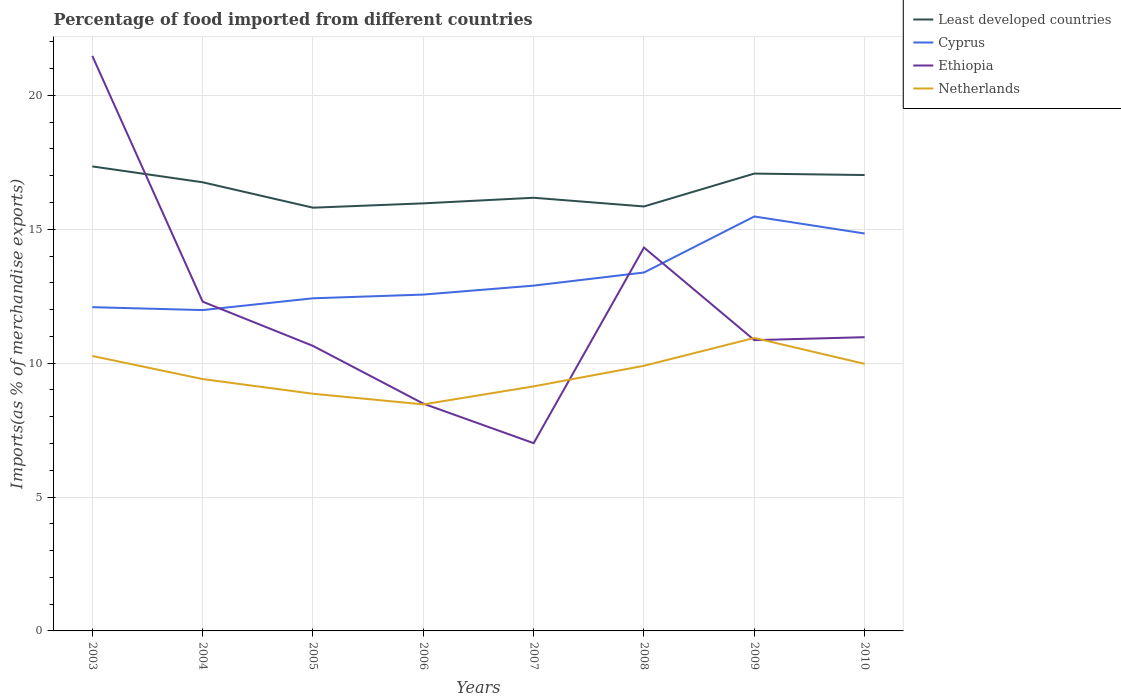How many different coloured lines are there?
Your answer should be compact. 4. Does the line corresponding to Least developed countries intersect with the line corresponding to Cyprus?
Offer a very short reply. No. Is the number of lines equal to the number of legend labels?
Your response must be concise. Yes. Across all years, what is the maximum percentage of imports to different countries in Netherlands?
Keep it short and to the point. 8.46. In which year was the percentage of imports to different countries in Ethiopia maximum?
Your answer should be compact. 2007. What is the total percentage of imports to different countries in Netherlands in the graph?
Ensure brevity in your answer.  0.4. What is the difference between the highest and the second highest percentage of imports to different countries in Ethiopia?
Provide a succinct answer. 14.46. What is the difference between the highest and the lowest percentage of imports to different countries in Least developed countries?
Provide a succinct answer. 4. How many years are there in the graph?
Offer a very short reply. 8. What is the difference between two consecutive major ticks on the Y-axis?
Ensure brevity in your answer.  5. Does the graph contain any zero values?
Make the answer very short. No. Does the graph contain grids?
Keep it short and to the point. Yes. Where does the legend appear in the graph?
Your response must be concise. Top right. What is the title of the graph?
Your response must be concise. Percentage of food imported from different countries. Does "East Asia (developing only)" appear as one of the legend labels in the graph?
Offer a very short reply. No. What is the label or title of the Y-axis?
Provide a succinct answer. Imports(as % of merchandise exports). What is the Imports(as % of merchandise exports) of Least developed countries in 2003?
Make the answer very short. 17.35. What is the Imports(as % of merchandise exports) of Cyprus in 2003?
Provide a short and direct response. 12.09. What is the Imports(as % of merchandise exports) of Ethiopia in 2003?
Offer a terse response. 21.47. What is the Imports(as % of merchandise exports) in Netherlands in 2003?
Provide a short and direct response. 10.27. What is the Imports(as % of merchandise exports) of Least developed countries in 2004?
Keep it short and to the point. 16.76. What is the Imports(as % of merchandise exports) in Cyprus in 2004?
Make the answer very short. 11.98. What is the Imports(as % of merchandise exports) in Ethiopia in 2004?
Provide a succinct answer. 12.3. What is the Imports(as % of merchandise exports) of Netherlands in 2004?
Give a very brief answer. 9.41. What is the Imports(as % of merchandise exports) of Least developed countries in 2005?
Offer a very short reply. 15.81. What is the Imports(as % of merchandise exports) in Cyprus in 2005?
Offer a very short reply. 12.42. What is the Imports(as % of merchandise exports) of Ethiopia in 2005?
Provide a succinct answer. 10.64. What is the Imports(as % of merchandise exports) in Netherlands in 2005?
Your answer should be very brief. 8.86. What is the Imports(as % of merchandise exports) in Least developed countries in 2006?
Your response must be concise. 15.97. What is the Imports(as % of merchandise exports) of Cyprus in 2006?
Provide a succinct answer. 12.56. What is the Imports(as % of merchandise exports) of Ethiopia in 2006?
Keep it short and to the point. 8.49. What is the Imports(as % of merchandise exports) of Netherlands in 2006?
Provide a short and direct response. 8.46. What is the Imports(as % of merchandise exports) in Least developed countries in 2007?
Your answer should be very brief. 16.18. What is the Imports(as % of merchandise exports) in Cyprus in 2007?
Provide a short and direct response. 12.9. What is the Imports(as % of merchandise exports) of Ethiopia in 2007?
Your response must be concise. 7.01. What is the Imports(as % of merchandise exports) in Netherlands in 2007?
Ensure brevity in your answer.  9.13. What is the Imports(as % of merchandise exports) in Least developed countries in 2008?
Offer a terse response. 15.85. What is the Imports(as % of merchandise exports) of Cyprus in 2008?
Your response must be concise. 13.39. What is the Imports(as % of merchandise exports) in Ethiopia in 2008?
Provide a succinct answer. 14.32. What is the Imports(as % of merchandise exports) in Netherlands in 2008?
Your answer should be compact. 9.9. What is the Imports(as % of merchandise exports) in Least developed countries in 2009?
Provide a short and direct response. 17.08. What is the Imports(as % of merchandise exports) of Cyprus in 2009?
Provide a succinct answer. 15.48. What is the Imports(as % of merchandise exports) in Ethiopia in 2009?
Your response must be concise. 10.86. What is the Imports(as % of merchandise exports) of Netherlands in 2009?
Ensure brevity in your answer.  10.94. What is the Imports(as % of merchandise exports) in Least developed countries in 2010?
Keep it short and to the point. 17.03. What is the Imports(as % of merchandise exports) in Cyprus in 2010?
Your answer should be very brief. 14.84. What is the Imports(as % of merchandise exports) of Ethiopia in 2010?
Provide a short and direct response. 10.97. What is the Imports(as % of merchandise exports) in Netherlands in 2010?
Your response must be concise. 9.97. Across all years, what is the maximum Imports(as % of merchandise exports) of Least developed countries?
Keep it short and to the point. 17.35. Across all years, what is the maximum Imports(as % of merchandise exports) in Cyprus?
Your answer should be very brief. 15.48. Across all years, what is the maximum Imports(as % of merchandise exports) of Ethiopia?
Your response must be concise. 21.47. Across all years, what is the maximum Imports(as % of merchandise exports) of Netherlands?
Ensure brevity in your answer.  10.94. Across all years, what is the minimum Imports(as % of merchandise exports) of Least developed countries?
Your answer should be very brief. 15.81. Across all years, what is the minimum Imports(as % of merchandise exports) in Cyprus?
Ensure brevity in your answer.  11.98. Across all years, what is the minimum Imports(as % of merchandise exports) of Ethiopia?
Your answer should be compact. 7.01. Across all years, what is the minimum Imports(as % of merchandise exports) of Netherlands?
Ensure brevity in your answer.  8.46. What is the total Imports(as % of merchandise exports) of Least developed countries in the graph?
Your answer should be compact. 132.02. What is the total Imports(as % of merchandise exports) in Cyprus in the graph?
Your response must be concise. 105.66. What is the total Imports(as % of merchandise exports) of Ethiopia in the graph?
Provide a short and direct response. 96.07. What is the total Imports(as % of merchandise exports) of Netherlands in the graph?
Make the answer very short. 76.95. What is the difference between the Imports(as % of merchandise exports) of Least developed countries in 2003 and that in 2004?
Your answer should be very brief. 0.59. What is the difference between the Imports(as % of merchandise exports) in Cyprus in 2003 and that in 2004?
Your answer should be compact. 0.11. What is the difference between the Imports(as % of merchandise exports) of Ethiopia in 2003 and that in 2004?
Offer a very short reply. 9.18. What is the difference between the Imports(as % of merchandise exports) in Netherlands in 2003 and that in 2004?
Make the answer very short. 0.86. What is the difference between the Imports(as % of merchandise exports) in Least developed countries in 2003 and that in 2005?
Your answer should be compact. 1.54. What is the difference between the Imports(as % of merchandise exports) of Cyprus in 2003 and that in 2005?
Keep it short and to the point. -0.33. What is the difference between the Imports(as % of merchandise exports) in Ethiopia in 2003 and that in 2005?
Ensure brevity in your answer.  10.83. What is the difference between the Imports(as % of merchandise exports) in Netherlands in 2003 and that in 2005?
Make the answer very short. 1.41. What is the difference between the Imports(as % of merchandise exports) in Least developed countries in 2003 and that in 2006?
Your answer should be compact. 1.38. What is the difference between the Imports(as % of merchandise exports) in Cyprus in 2003 and that in 2006?
Keep it short and to the point. -0.47. What is the difference between the Imports(as % of merchandise exports) of Ethiopia in 2003 and that in 2006?
Make the answer very short. 12.99. What is the difference between the Imports(as % of merchandise exports) in Netherlands in 2003 and that in 2006?
Keep it short and to the point. 1.81. What is the difference between the Imports(as % of merchandise exports) in Least developed countries in 2003 and that in 2007?
Offer a very short reply. 1.17. What is the difference between the Imports(as % of merchandise exports) in Cyprus in 2003 and that in 2007?
Make the answer very short. -0.81. What is the difference between the Imports(as % of merchandise exports) of Ethiopia in 2003 and that in 2007?
Your response must be concise. 14.46. What is the difference between the Imports(as % of merchandise exports) in Netherlands in 2003 and that in 2007?
Your answer should be compact. 1.14. What is the difference between the Imports(as % of merchandise exports) of Least developed countries in 2003 and that in 2008?
Offer a terse response. 1.5. What is the difference between the Imports(as % of merchandise exports) in Cyprus in 2003 and that in 2008?
Your answer should be very brief. -1.29. What is the difference between the Imports(as % of merchandise exports) of Ethiopia in 2003 and that in 2008?
Provide a short and direct response. 7.16. What is the difference between the Imports(as % of merchandise exports) of Netherlands in 2003 and that in 2008?
Provide a short and direct response. 0.37. What is the difference between the Imports(as % of merchandise exports) of Least developed countries in 2003 and that in 2009?
Your response must be concise. 0.27. What is the difference between the Imports(as % of merchandise exports) in Cyprus in 2003 and that in 2009?
Provide a short and direct response. -3.39. What is the difference between the Imports(as % of merchandise exports) of Ethiopia in 2003 and that in 2009?
Your answer should be very brief. 10.61. What is the difference between the Imports(as % of merchandise exports) of Netherlands in 2003 and that in 2009?
Make the answer very short. -0.67. What is the difference between the Imports(as % of merchandise exports) of Least developed countries in 2003 and that in 2010?
Offer a very short reply. 0.32. What is the difference between the Imports(as % of merchandise exports) of Cyprus in 2003 and that in 2010?
Offer a terse response. -2.75. What is the difference between the Imports(as % of merchandise exports) in Ethiopia in 2003 and that in 2010?
Provide a succinct answer. 10.5. What is the difference between the Imports(as % of merchandise exports) in Netherlands in 2003 and that in 2010?
Your answer should be very brief. 0.29. What is the difference between the Imports(as % of merchandise exports) in Least developed countries in 2004 and that in 2005?
Provide a succinct answer. 0.95. What is the difference between the Imports(as % of merchandise exports) in Cyprus in 2004 and that in 2005?
Offer a very short reply. -0.44. What is the difference between the Imports(as % of merchandise exports) of Ethiopia in 2004 and that in 2005?
Provide a short and direct response. 1.65. What is the difference between the Imports(as % of merchandise exports) of Netherlands in 2004 and that in 2005?
Provide a succinct answer. 0.55. What is the difference between the Imports(as % of merchandise exports) of Least developed countries in 2004 and that in 2006?
Ensure brevity in your answer.  0.79. What is the difference between the Imports(as % of merchandise exports) of Cyprus in 2004 and that in 2006?
Ensure brevity in your answer.  -0.58. What is the difference between the Imports(as % of merchandise exports) of Ethiopia in 2004 and that in 2006?
Make the answer very short. 3.81. What is the difference between the Imports(as % of merchandise exports) of Netherlands in 2004 and that in 2006?
Ensure brevity in your answer.  0.95. What is the difference between the Imports(as % of merchandise exports) in Least developed countries in 2004 and that in 2007?
Offer a terse response. 0.58. What is the difference between the Imports(as % of merchandise exports) of Cyprus in 2004 and that in 2007?
Give a very brief answer. -0.91. What is the difference between the Imports(as % of merchandise exports) of Ethiopia in 2004 and that in 2007?
Make the answer very short. 5.28. What is the difference between the Imports(as % of merchandise exports) of Netherlands in 2004 and that in 2007?
Your answer should be compact. 0.27. What is the difference between the Imports(as % of merchandise exports) of Least developed countries in 2004 and that in 2008?
Ensure brevity in your answer.  0.9. What is the difference between the Imports(as % of merchandise exports) in Cyprus in 2004 and that in 2008?
Give a very brief answer. -1.4. What is the difference between the Imports(as % of merchandise exports) of Ethiopia in 2004 and that in 2008?
Keep it short and to the point. -2.02. What is the difference between the Imports(as % of merchandise exports) in Netherlands in 2004 and that in 2008?
Your answer should be compact. -0.5. What is the difference between the Imports(as % of merchandise exports) of Least developed countries in 2004 and that in 2009?
Provide a short and direct response. -0.32. What is the difference between the Imports(as % of merchandise exports) of Cyprus in 2004 and that in 2009?
Provide a succinct answer. -3.5. What is the difference between the Imports(as % of merchandise exports) of Ethiopia in 2004 and that in 2009?
Offer a terse response. 1.44. What is the difference between the Imports(as % of merchandise exports) of Netherlands in 2004 and that in 2009?
Keep it short and to the point. -1.54. What is the difference between the Imports(as % of merchandise exports) of Least developed countries in 2004 and that in 2010?
Your answer should be compact. -0.27. What is the difference between the Imports(as % of merchandise exports) of Cyprus in 2004 and that in 2010?
Your answer should be compact. -2.86. What is the difference between the Imports(as % of merchandise exports) in Ethiopia in 2004 and that in 2010?
Give a very brief answer. 1.33. What is the difference between the Imports(as % of merchandise exports) of Netherlands in 2004 and that in 2010?
Ensure brevity in your answer.  -0.57. What is the difference between the Imports(as % of merchandise exports) in Least developed countries in 2005 and that in 2006?
Offer a terse response. -0.16. What is the difference between the Imports(as % of merchandise exports) of Cyprus in 2005 and that in 2006?
Provide a short and direct response. -0.14. What is the difference between the Imports(as % of merchandise exports) in Ethiopia in 2005 and that in 2006?
Give a very brief answer. 2.16. What is the difference between the Imports(as % of merchandise exports) in Netherlands in 2005 and that in 2006?
Your answer should be very brief. 0.4. What is the difference between the Imports(as % of merchandise exports) of Least developed countries in 2005 and that in 2007?
Your answer should be very brief. -0.37. What is the difference between the Imports(as % of merchandise exports) in Cyprus in 2005 and that in 2007?
Offer a very short reply. -0.47. What is the difference between the Imports(as % of merchandise exports) of Ethiopia in 2005 and that in 2007?
Your answer should be compact. 3.63. What is the difference between the Imports(as % of merchandise exports) of Netherlands in 2005 and that in 2007?
Your answer should be very brief. -0.28. What is the difference between the Imports(as % of merchandise exports) in Least developed countries in 2005 and that in 2008?
Make the answer very short. -0.05. What is the difference between the Imports(as % of merchandise exports) in Cyprus in 2005 and that in 2008?
Offer a terse response. -0.96. What is the difference between the Imports(as % of merchandise exports) in Ethiopia in 2005 and that in 2008?
Keep it short and to the point. -3.67. What is the difference between the Imports(as % of merchandise exports) of Netherlands in 2005 and that in 2008?
Offer a very short reply. -1.04. What is the difference between the Imports(as % of merchandise exports) of Least developed countries in 2005 and that in 2009?
Your response must be concise. -1.27. What is the difference between the Imports(as % of merchandise exports) of Cyprus in 2005 and that in 2009?
Give a very brief answer. -3.06. What is the difference between the Imports(as % of merchandise exports) of Ethiopia in 2005 and that in 2009?
Your response must be concise. -0.22. What is the difference between the Imports(as % of merchandise exports) in Netherlands in 2005 and that in 2009?
Your answer should be compact. -2.08. What is the difference between the Imports(as % of merchandise exports) in Least developed countries in 2005 and that in 2010?
Offer a terse response. -1.22. What is the difference between the Imports(as % of merchandise exports) in Cyprus in 2005 and that in 2010?
Offer a very short reply. -2.42. What is the difference between the Imports(as % of merchandise exports) of Ethiopia in 2005 and that in 2010?
Your answer should be very brief. -0.33. What is the difference between the Imports(as % of merchandise exports) of Netherlands in 2005 and that in 2010?
Provide a short and direct response. -1.12. What is the difference between the Imports(as % of merchandise exports) in Least developed countries in 2006 and that in 2007?
Offer a very short reply. -0.21. What is the difference between the Imports(as % of merchandise exports) of Cyprus in 2006 and that in 2007?
Your response must be concise. -0.33. What is the difference between the Imports(as % of merchandise exports) of Ethiopia in 2006 and that in 2007?
Provide a succinct answer. 1.48. What is the difference between the Imports(as % of merchandise exports) of Netherlands in 2006 and that in 2007?
Offer a terse response. -0.67. What is the difference between the Imports(as % of merchandise exports) of Least developed countries in 2006 and that in 2008?
Provide a succinct answer. 0.12. What is the difference between the Imports(as % of merchandise exports) of Cyprus in 2006 and that in 2008?
Offer a very short reply. -0.82. What is the difference between the Imports(as % of merchandise exports) of Ethiopia in 2006 and that in 2008?
Provide a succinct answer. -5.83. What is the difference between the Imports(as % of merchandise exports) of Netherlands in 2006 and that in 2008?
Make the answer very short. -1.44. What is the difference between the Imports(as % of merchandise exports) in Least developed countries in 2006 and that in 2009?
Offer a terse response. -1.11. What is the difference between the Imports(as % of merchandise exports) of Cyprus in 2006 and that in 2009?
Your answer should be very brief. -2.92. What is the difference between the Imports(as % of merchandise exports) in Ethiopia in 2006 and that in 2009?
Ensure brevity in your answer.  -2.37. What is the difference between the Imports(as % of merchandise exports) of Netherlands in 2006 and that in 2009?
Your response must be concise. -2.48. What is the difference between the Imports(as % of merchandise exports) of Least developed countries in 2006 and that in 2010?
Provide a succinct answer. -1.06. What is the difference between the Imports(as % of merchandise exports) in Cyprus in 2006 and that in 2010?
Your answer should be very brief. -2.28. What is the difference between the Imports(as % of merchandise exports) of Ethiopia in 2006 and that in 2010?
Provide a short and direct response. -2.48. What is the difference between the Imports(as % of merchandise exports) of Netherlands in 2006 and that in 2010?
Provide a short and direct response. -1.51. What is the difference between the Imports(as % of merchandise exports) in Least developed countries in 2007 and that in 2008?
Provide a short and direct response. 0.33. What is the difference between the Imports(as % of merchandise exports) in Cyprus in 2007 and that in 2008?
Make the answer very short. -0.49. What is the difference between the Imports(as % of merchandise exports) of Ethiopia in 2007 and that in 2008?
Your response must be concise. -7.31. What is the difference between the Imports(as % of merchandise exports) of Netherlands in 2007 and that in 2008?
Provide a succinct answer. -0.77. What is the difference between the Imports(as % of merchandise exports) in Least developed countries in 2007 and that in 2009?
Offer a very short reply. -0.9. What is the difference between the Imports(as % of merchandise exports) in Cyprus in 2007 and that in 2009?
Offer a very short reply. -2.58. What is the difference between the Imports(as % of merchandise exports) in Ethiopia in 2007 and that in 2009?
Your response must be concise. -3.85. What is the difference between the Imports(as % of merchandise exports) of Netherlands in 2007 and that in 2009?
Your response must be concise. -1.81. What is the difference between the Imports(as % of merchandise exports) in Least developed countries in 2007 and that in 2010?
Your answer should be very brief. -0.85. What is the difference between the Imports(as % of merchandise exports) in Cyprus in 2007 and that in 2010?
Your answer should be very brief. -1.95. What is the difference between the Imports(as % of merchandise exports) of Ethiopia in 2007 and that in 2010?
Offer a very short reply. -3.96. What is the difference between the Imports(as % of merchandise exports) of Netherlands in 2007 and that in 2010?
Give a very brief answer. -0.84. What is the difference between the Imports(as % of merchandise exports) in Least developed countries in 2008 and that in 2009?
Keep it short and to the point. -1.23. What is the difference between the Imports(as % of merchandise exports) in Cyprus in 2008 and that in 2009?
Offer a very short reply. -2.09. What is the difference between the Imports(as % of merchandise exports) of Ethiopia in 2008 and that in 2009?
Keep it short and to the point. 3.46. What is the difference between the Imports(as % of merchandise exports) of Netherlands in 2008 and that in 2009?
Provide a short and direct response. -1.04. What is the difference between the Imports(as % of merchandise exports) of Least developed countries in 2008 and that in 2010?
Give a very brief answer. -1.17. What is the difference between the Imports(as % of merchandise exports) in Cyprus in 2008 and that in 2010?
Your answer should be very brief. -1.46. What is the difference between the Imports(as % of merchandise exports) in Ethiopia in 2008 and that in 2010?
Offer a terse response. 3.35. What is the difference between the Imports(as % of merchandise exports) of Netherlands in 2008 and that in 2010?
Keep it short and to the point. -0.07. What is the difference between the Imports(as % of merchandise exports) in Least developed countries in 2009 and that in 2010?
Provide a short and direct response. 0.05. What is the difference between the Imports(as % of merchandise exports) of Cyprus in 2009 and that in 2010?
Provide a short and direct response. 0.64. What is the difference between the Imports(as % of merchandise exports) of Ethiopia in 2009 and that in 2010?
Give a very brief answer. -0.11. What is the difference between the Imports(as % of merchandise exports) of Netherlands in 2009 and that in 2010?
Offer a very short reply. 0.97. What is the difference between the Imports(as % of merchandise exports) in Least developed countries in 2003 and the Imports(as % of merchandise exports) in Cyprus in 2004?
Make the answer very short. 5.37. What is the difference between the Imports(as % of merchandise exports) of Least developed countries in 2003 and the Imports(as % of merchandise exports) of Ethiopia in 2004?
Make the answer very short. 5.05. What is the difference between the Imports(as % of merchandise exports) of Least developed countries in 2003 and the Imports(as % of merchandise exports) of Netherlands in 2004?
Ensure brevity in your answer.  7.94. What is the difference between the Imports(as % of merchandise exports) of Cyprus in 2003 and the Imports(as % of merchandise exports) of Ethiopia in 2004?
Give a very brief answer. -0.21. What is the difference between the Imports(as % of merchandise exports) of Cyprus in 2003 and the Imports(as % of merchandise exports) of Netherlands in 2004?
Your answer should be very brief. 2.69. What is the difference between the Imports(as % of merchandise exports) of Ethiopia in 2003 and the Imports(as % of merchandise exports) of Netherlands in 2004?
Offer a very short reply. 12.07. What is the difference between the Imports(as % of merchandise exports) of Least developed countries in 2003 and the Imports(as % of merchandise exports) of Cyprus in 2005?
Your answer should be compact. 4.93. What is the difference between the Imports(as % of merchandise exports) of Least developed countries in 2003 and the Imports(as % of merchandise exports) of Ethiopia in 2005?
Your answer should be compact. 6.7. What is the difference between the Imports(as % of merchandise exports) in Least developed countries in 2003 and the Imports(as % of merchandise exports) in Netherlands in 2005?
Offer a terse response. 8.49. What is the difference between the Imports(as % of merchandise exports) of Cyprus in 2003 and the Imports(as % of merchandise exports) of Ethiopia in 2005?
Keep it short and to the point. 1.45. What is the difference between the Imports(as % of merchandise exports) in Cyprus in 2003 and the Imports(as % of merchandise exports) in Netherlands in 2005?
Make the answer very short. 3.23. What is the difference between the Imports(as % of merchandise exports) in Ethiopia in 2003 and the Imports(as % of merchandise exports) in Netherlands in 2005?
Your response must be concise. 12.62. What is the difference between the Imports(as % of merchandise exports) of Least developed countries in 2003 and the Imports(as % of merchandise exports) of Cyprus in 2006?
Provide a succinct answer. 4.79. What is the difference between the Imports(as % of merchandise exports) of Least developed countries in 2003 and the Imports(as % of merchandise exports) of Ethiopia in 2006?
Offer a very short reply. 8.86. What is the difference between the Imports(as % of merchandise exports) in Least developed countries in 2003 and the Imports(as % of merchandise exports) in Netherlands in 2006?
Keep it short and to the point. 8.89. What is the difference between the Imports(as % of merchandise exports) in Cyprus in 2003 and the Imports(as % of merchandise exports) in Ethiopia in 2006?
Offer a very short reply. 3.6. What is the difference between the Imports(as % of merchandise exports) of Cyprus in 2003 and the Imports(as % of merchandise exports) of Netherlands in 2006?
Your answer should be very brief. 3.63. What is the difference between the Imports(as % of merchandise exports) of Ethiopia in 2003 and the Imports(as % of merchandise exports) of Netherlands in 2006?
Provide a short and direct response. 13.01. What is the difference between the Imports(as % of merchandise exports) of Least developed countries in 2003 and the Imports(as % of merchandise exports) of Cyprus in 2007?
Give a very brief answer. 4.45. What is the difference between the Imports(as % of merchandise exports) in Least developed countries in 2003 and the Imports(as % of merchandise exports) in Ethiopia in 2007?
Provide a short and direct response. 10.34. What is the difference between the Imports(as % of merchandise exports) in Least developed countries in 2003 and the Imports(as % of merchandise exports) in Netherlands in 2007?
Provide a short and direct response. 8.21. What is the difference between the Imports(as % of merchandise exports) in Cyprus in 2003 and the Imports(as % of merchandise exports) in Ethiopia in 2007?
Your response must be concise. 5.08. What is the difference between the Imports(as % of merchandise exports) in Cyprus in 2003 and the Imports(as % of merchandise exports) in Netherlands in 2007?
Offer a terse response. 2.96. What is the difference between the Imports(as % of merchandise exports) in Ethiopia in 2003 and the Imports(as % of merchandise exports) in Netherlands in 2007?
Offer a very short reply. 12.34. What is the difference between the Imports(as % of merchandise exports) of Least developed countries in 2003 and the Imports(as % of merchandise exports) of Cyprus in 2008?
Your answer should be very brief. 3.96. What is the difference between the Imports(as % of merchandise exports) in Least developed countries in 2003 and the Imports(as % of merchandise exports) in Ethiopia in 2008?
Give a very brief answer. 3.03. What is the difference between the Imports(as % of merchandise exports) of Least developed countries in 2003 and the Imports(as % of merchandise exports) of Netherlands in 2008?
Offer a terse response. 7.45. What is the difference between the Imports(as % of merchandise exports) of Cyprus in 2003 and the Imports(as % of merchandise exports) of Ethiopia in 2008?
Offer a terse response. -2.23. What is the difference between the Imports(as % of merchandise exports) in Cyprus in 2003 and the Imports(as % of merchandise exports) in Netherlands in 2008?
Offer a terse response. 2.19. What is the difference between the Imports(as % of merchandise exports) of Ethiopia in 2003 and the Imports(as % of merchandise exports) of Netherlands in 2008?
Give a very brief answer. 11.57. What is the difference between the Imports(as % of merchandise exports) of Least developed countries in 2003 and the Imports(as % of merchandise exports) of Cyprus in 2009?
Ensure brevity in your answer.  1.87. What is the difference between the Imports(as % of merchandise exports) in Least developed countries in 2003 and the Imports(as % of merchandise exports) in Ethiopia in 2009?
Ensure brevity in your answer.  6.49. What is the difference between the Imports(as % of merchandise exports) in Least developed countries in 2003 and the Imports(as % of merchandise exports) in Netherlands in 2009?
Keep it short and to the point. 6.41. What is the difference between the Imports(as % of merchandise exports) in Cyprus in 2003 and the Imports(as % of merchandise exports) in Ethiopia in 2009?
Your response must be concise. 1.23. What is the difference between the Imports(as % of merchandise exports) in Cyprus in 2003 and the Imports(as % of merchandise exports) in Netherlands in 2009?
Make the answer very short. 1.15. What is the difference between the Imports(as % of merchandise exports) of Ethiopia in 2003 and the Imports(as % of merchandise exports) of Netherlands in 2009?
Your response must be concise. 10.53. What is the difference between the Imports(as % of merchandise exports) of Least developed countries in 2003 and the Imports(as % of merchandise exports) of Cyprus in 2010?
Provide a short and direct response. 2.51. What is the difference between the Imports(as % of merchandise exports) of Least developed countries in 2003 and the Imports(as % of merchandise exports) of Ethiopia in 2010?
Your answer should be compact. 6.38. What is the difference between the Imports(as % of merchandise exports) of Least developed countries in 2003 and the Imports(as % of merchandise exports) of Netherlands in 2010?
Offer a terse response. 7.37. What is the difference between the Imports(as % of merchandise exports) of Cyprus in 2003 and the Imports(as % of merchandise exports) of Ethiopia in 2010?
Your response must be concise. 1.12. What is the difference between the Imports(as % of merchandise exports) of Cyprus in 2003 and the Imports(as % of merchandise exports) of Netherlands in 2010?
Offer a terse response. 2.12. What is the difference between the Imports(as % of merchandise exports) of Ethiopia in 2003 and the Imports(as % of merchandise exports) of Netherlands in 2010?
Offer a terse response. 11.5. What is the difference between the Imports(as % of merchandise exports) in Least developed countries in 2004 and the Imports(as % of merchandise exports) in Cyprus in 2005?
Make the answer very short. 4.33. What is the difference between the Imports(as % of merchandise exports) of Least developed countries in 2004 and the Imports(as % of merchandise exports) of Ethiopia in 2005?
Offer a very short reply. 6.11. What is the difference between the Imports(as % of merchandise exports) in Least developed countries in 2004 and the Imports(as % of merchandise exports) in Netherlands in 2005?
Provide a short and direct response. 7.9. What is the difference between the Imports(as % of merchandise exports) of Cyprus in 2004 and the Imports(as % of merchandise exports) of Ethiopia in 2005?
Keep it short and to the point. 1.34. What is the difference between the Imports(as % of merchandise exports) of Cyprus in 2004 and the Imports(as % of merchandise exports) of Netherlands in 2005?
Provide a succinct answer. 3.13. What is the difference between the Imports(as % of merchandise exports) in Ethiopia in 2004 and the Imports(as % of merchandise exports) in Netherlands in 2005?
Keep it short and to the point. 3.44. What is the difference between the Imports(as % of merchandise exports) of Least developed countries in 2004 and the Imports(as % of merchandise exports) of Cyprus in 2006?
Ensure brevity in your answer.  4.19. What is the difference between the Imports(as % of merchandise exports) of Least developed countries in 2004 and the Imports(as % of merchandise exports) of Ethiopia in 2006?
Provide a succinct answer. 8.27. What is the difference between the Imports(as % of merchandise exports) of Least developed countries in 2004 and the Imports(as % of merchandise exports) of Netherlands in 2006?
Give a very brief answer. 8.3. What is the difference between the Imports(as % of merchandise exports) in Cyprus in 2004 and the Imports(as % of merchandise exports) in Ethiopia in 2006?
Keep it short and to the point. 3.49. What is the difference between the Imports(as % of merchandise exports) in Cyprus in 2004 and the Imports(as % of merchandise exports) in Netherlands in 2006?
Offer a very short reply. 3.52. What is the difference between the Imports(as % of merchandise exports) in Ethiopia in 2004 and the Imports(as % of merchandise exports) in Netherlands in 2006?
Give a very brief answer. 3.84. What is the difference between the Imports(as % of merchandise exports) of Least developed countries in 2004 and the Imports(as % of merchandise exports) of Cyprus in 2007?
Your response must be concise. 3.86. What is the difference between the Imports(as % of merchandise exports) of Least developed countries in 2004 and the Imports(as % of merchandise exports) of Ethiopia in 2007?
Your response must be concise. 9.74. What is the difference between the Imports(as % of merchandise exports) in Least developed countries in 2004 and the Imports(as % of merchandise exports) in Netherlands in 2007?
Your answer should be compact. 7.62. What is the difference between the Imports(as % of merchandise exports) in Cyprus in 2004 and the Imports(as % of merchandise exports) in Ethiopia in 2007?
Offer a very short reply. 4.97. What is the difference between the Imports(as % of merchandise exports) in Cyprus in 2004 and the Imports(as % of merchandise exports) in Netherlands in 2007?
Your answer should be compact. 2.85. What is the difference between the Imports(as % of merchandise exports) of Ethiopia in 2004 and the Imports(as % of merchandise exports) of Netherlands in 2007?
Provide a succinct answer. 3.16. What is the difference between the Imports(as % of merchandise exports) in Least developed countries in 2004 and the Imports(as % of merchandise exports) in Cyprus in 2008?
Make the answer very short. 3.37. What is the difference between the Imports(as % of merchandise exports) of Least developed countries in 2004 and the Imports(as % of merchandise exports) of Ethiopia in 2008?
Make the answer very short. 2.44. What is the difference between the Imports(as % of merchandise exports) of Least developed countries in 2004 and the Imports(as % of merchandise exports) of Netherlands in 2008?
Provide a succinct answer. 6.85. What is the difference between the Imports(as % of merchandise exports) in Cyprus in 2004 and the Imports(as % of merchandise exports) in Ethiopia in 2008?
Provide a succinct answer. -2.34. What is the difference between the Imports(as % of merchandise exports) in Cyprus in 2004 and the Imports(as % of merchandise exports) in Netherlands in 2008?
Provide a short and direct response. 2.08. What is the difference between the Imports(as % of merchandise exports) of Ethiopia in 2004 and the Imports(as % of merchandise exports) of Netherlands in 2008?
Ensure brevity in your answer.  2.39. What is the difference between the Imports(as % of merchandise exports) in Least developed countries in 2004 and the Imports(as % of merchandise exports) in Cyprus in 2009?
Make the answer very short. 1.28. What is the difference between the Imports(as % of merchandise exports) of Least developed countries in 2004 and the Imports(as % of merchandise exports) of Ethiopia in 2009?
Give a very brief answer. 5.9. What is the difference between the Imports(as % of merchandise exports) of Least developed countries in 2004 and the Imports(as % of merchandise exports) of Netherlands in 2009?
Make the answer very short. 5.81. What is the difference between the Imports(as % of merchandise exports) in Cyprus in 2004 and the Imports(as % of merchandise exports) in Ethiopia in 2009?
Give a very brief answer. 1.12. What is the difference between the Imports(as % of merchandise exports) in Cyprus in 2004 and the Imports(as % of merchandise exports) in Netherlands in 2009?
Your answer should be compact. 1.04. What is the difference between the Imports(as % of merchandise exports) of Ethiopia in 2004 and the Imports(as % of merchandise exports) of Netherlands in 2009?
Keep it short and to the point. 1.35. What is the difference between the Imports(as % of merchandise exports) in Least developed countries in 2004 and the Imports(as % of merchandise exports) in Cyprus in 2010?
Provide a short and direct response. 1.91. What is the difference between the Imports(as % of merchandise exports) of Least developed countries in 2004 and the Imports(as % of merchandise exports) of Ethiopia in 2010?
Provide a short and direct response. 5.79. What is the difference between the Imports(as % of merchandise exports) of Least developed countries in 2004 and the Imports(as % of merchandise exports) of Netherlands in 2010?
Make the answer very short. 6.78. What is the difference between the Imports(as % of merchandise exports) of Cyprus in 2004 and the Imports(as % of merchandise exports) of Ethiopia in 2010?
Keep it short and to the point. 1.01. What is the difference between the Imports(as % of merchandise exports) in Cyprus in 2004 and the Imports(as % of merchandise exports) in Netherlands in 2010?
Offer a very short reply. 2.01. What is the difference between the Imports(as % of merchandise exports) in Ethiopia in 2004 and the Imports(as % of merchandise exports) in Netherlands in 2010?
Provide a short and direct response. 2.32. What is the difference between the Imports(as % of merchandise exports) in Least developed countries in 2005 and the Imports(as % of merchandise exports) in Cyprus in 2006?
Give a very brief answer. 3.25. What is the difference between the Imports(as % of merchandise exports) of Least developed countries in 2005 and the Imports(as % of merchandise exports) of Ethiopia in 2006?
Give a very brief answer. 7.32. What is the difference between the Imports(as % of merchandise exports) of Least developed countries in 2005 and the Imports(as % of merchandise exports) of Netherlands in 2006?
Offer a terse response. 7.35. What is the difference between the Imports(as % of merchandise exports) of Cyprus in 2005 and the Imports(as % of merchandise exports) of Ethiopia in 2006?
Make the answer very short. 3.93. What is the difference between the Imports(as % of merchandise exports) of Cyprus in 2005 and the Imports(as % of merchandise exports) of Netherlands in 2006?
Make the answer very short. 3.96. What is the difference between the Imports(as % of merchandise exports) in Ethiopia in 2005 and the Imports(as % of merchandise exports) in Netherlands in 2006?
Your answer should be compact. 2.18. What is the difference between the Imports(as % of merchandise exports) in Least developed countries in 2005 and the Imports(as % of merchandise exports) in Cyprus in 2007?
Offer a terse response. 2.91. What is the difference between the Imports(as % of merchandise exports) of Least developed countries in 2005 and the Imports(as % of merchandise exports) of Ethiopia in 2007?
Your response must be concise. 8.79. What is the difference between the Imports(as % of merchandise exports) of Least developed countries in 2005 and the Imports(as % of merchandise exports) of Netherlands in 2007?
Your answer should be compact. 6.67. What is the difference between the Imports(as % of merchandise exports) in Cyprus in 2005 and the Imports(as % of merchandise exports) in Ethiopia in 2007?
Offer a very short reply. 5.41. What is the difference between the Imports(as % of merchandise exports) of Cyprus in 2005 and the Imports(as % of merchandise exports) of Netherlands in 2007?
Ensure brevity in your answer.  3.29. What is the difference between the Imports(as % of merchandise exports) of Ethiopia in 2005 and the Imports(as % of merchandise exports) of Netherlands in 2007?
Ensure brevity in your answer.  1.51. What is the difference between the Imports(as % of merchandise exports) of Least developed countries in 2005 and the Imports(as % of merchandise exports) of Cyprus in 2008?
Your answer should be very brief. 2.42. What is the difference between the Imports(as % of merchandise exports) in Least developed countries in 2005 and the Imports(as % of merchandise exports) in Ethiopia in 2008?
Provide a succinct answer. 1.49. What is the difference between the Imports(as % of merchandise exports) of Least developed countries in 2005 and the Imports(as % of merchandise exports) of Netherlands in 2008?
Make the answer very short. 5.9. What is the difference between the Imports(as % of merchandise exports) of Cyprus in 2005 and the Imports(as % of merchandise exports) of Ethiopia in 2008?
Make the answer very short. -1.9. What is the difference between the Imports(as % of merchandise exports) of Cyprus in 2005 and the Imports(as % of merchandise exports) of Netherlands in 2008?
Keep it short and to the point. 2.52. What is the difference between the Imports(as % of merchandise exports) in Ethiopia in 2005 and the Imports(as % of merchandise exports) in Netherlands in 2008?
Keep it short and to the point. 0.74. What is the difference between the Imports(as % of merchandise exports) of Least developed countries in 2005 and the Imports(as % of merchandise exports) of Cyprus in 2009?
Keep it short and to the point. 0.33. What is the difference between the Imports(as % of merchandise exports) in Least developed countries in 2005 and the Imports(as % of merchandise exports) in Ethiopia in 2009?
Provide a short and direct response. 4.95. What is the difference between the Imports(as % of merchandise exports) in Least developed countries in 2005 and the Imports(as % of merchandise exports) in Netherlands in 2009?
Keep it short and to the point. 4.86. What is the difference between the Imports(as % of merchandise exports) of Cyprus in 2005 and the Imports(as % of merchandise exports) of Ethiopia in 2009?
Your response must be concise. 1.56. What is the difference between the Imports(as % of merchandise exports) of Cyprus in 2005 and the Imports(as % of merchandise exports) of Netherlands in 2009?
Offer a terse response. 1.48. What is the difference between the Imports(as % of merchandise exports) of Ethiopia in 2005 and the Imports(as % of merchandise exports) of Netherlands in 2009?
Offer a very short reply. -0.3. What is the difference between the Imports(as % of merchandise exports) of Least developed countries in 2005 and the Imports(as % of merchandise exports) of Cyprus in 2010?
Keep it short and to the point. 0.96. What is the difference between the Imports(as % of merchandise exports) in Least developed countries in 2005 and the Imports(as % of merchandise exports) in Ethiopia in 2010?
Provide a succinct answer. 4.84. What is the difference between the Imports(as % of merchandise exports) of Least developed countries in 2005 and the Imports(as % of merchandise exports) of Netherlands in 2010?
Your response must be concise. 5.83. What is the difference between the Imports(as % of merchandise exports) in Cyprus in 2005 and the Imports(as % of merchandise exports) in Ethiopia in 2010?
Keep it short and to the point. 1.45. What is the difference between the Imports(as % of merchandise exports) in Cyprus in 2005 and the Imports(as % of merchandise exports) in Netherlands in 2010?
Give a very brief answer. 2.45. What is the difference between the Imports(as % of merchandise exports) in Ethiopia in 2005 and the Imports(as % of merchandise exports) in Netherlands in 2010?
Provide a short and direct response. 0.67. What is the difference between the Imports(as % of merchandise exports) in Least developed countries in 2006 and the Imports(as % of merchandise exports) in Cyprus in 2007?
Provide a succinct answer. 3.07. What is the difference between the Imports(as % of merchandise exports) of Least developed countries in 2006 and the Imports(as % of merchandise exports) of Ethiopia in 2007?
Make the answer very short. 8.96. What is the difference between the Imports(as % of merchandise exports) of Least developed countries in 2006 and the Imports(as % of merchandise exports) of Netherlands in 2007?
Your answer should be very brief. 6.84. What is the difference between the Imports(as % of merchandise exports) of Cyprus in 2006 and the Imports(as % of merchandise exports) of Ethiopia in 2007?
Ensure brevity in your answer.  5.55. What is the difference between the Imports(as % of merchandise exports) of Cyprus in 2006 and the Imports(as % of merchandise exports) of Netherlands in 2007?
Offer a terse response. 3.43. What is the difference between the Imports(as % of merchandise exports) of Ethiopia in 2006 and the Imports(as % of merchandise exports) of Netherlands in 2007?
Offer a very short reply. -0.64. What is the difference between the Imports(as % of merchandise exports) in Least developed countries in 2006 and the Imports(as % of merchandise exports) in Cyprus in 2008?
Make the answer very short. 2.58. What is the difference between the Imports(as % of merchandise exports) in Least developed countries in 2006 and the Imports(as % of merchandise exports) in Ethiopia in 2008?
Keep it short and to the point. 1.65. What is the difference between the Imports(as % of merchandise exports) of Least developed countries in 2006 and the Imports(as % of merchandise exports) of Netherlands in 2008?
Ensure brevity in your answer.  6.07. What is the difference between the Imports(as % of merchandise exports) of Cyprus in 2006 and the Imports(as % of merchandise exports) of Ethiopia in 2008?
Your answer should be compact. -1.76. What is the difference between the Imports(as % of merchandise exports) in Cyprus in 2006 and the Imports(as % of merchandise exports) in Netherlands in 2008?
Give a very brief answer. 2.66. What is the difference between the Imports(as % of merchandise exports) in Ethiopia in 2006 and the Imports(as % of merchandise exports) in Netherlands in 2008?
Your answer should be very brief. -1.41. What is the difference between the Imports(as % of merchandise exports) in Least developed countries in 2006 and the Imports(as % of merchandise exports) in Cyprus in 2009?
Offer a very short reply. 0.49. What is the difference between the Imports(as % of merchandise exports) in Least developed countries in 2006 and the Imports(as % of merchandise exports) in Ethiopia in 2009?
Provide a succinct answer. 5.11. What is the difference between the Imports(as % of merchandise exports) in Least developed countries in 2006 and the Imports(as % of merchandise exports) in Netherlands in 2009?
Your answer should be compact. 5.03. What is the difference between the Imports(as % of merchandise exports) in Cyprus in 2006 and the Imports(as % of merchandise exports) in Ethiopia in 2009?
Make the answer very short. 1.7. What is the difference between the Imports(as % of merchandise exports) of Cyprus in 2006 and the Imports(as % of merchandise exports) of Netherlands in 2009?
Give a very brief answer. 1.62. What is the difference between the Imports(as % of merchandise exports) in Ethiopia in 2006 and the Imports(as % of merchandise exports) in Netherlands in 2009?
Offer a terse response. -2.45. What is the difference between the Imports(as % of merchandise exports) of Least developed countries in 2006 and the Imports(as % of merchandise exports) of Cyprus in 2010?
Your answer should be compact. 1.13. What is the difference between the Imports(as % of merchandise exports) in Least developed countries in 2006 and the Imports(as % of merchandise exports) in Ethiopia in 2010?
Provide a short and direct response. 5. What is the difference between the Imports(as % of merchandise exports) in Least developed countries in 2006 and the Imports(as % of merchandise exports) in Netherlands in 2010?
Offer a very short reply. 5.99. What is the difference between the Imports(as % of merchandise exports) in Cyprus in 2006 and the Imports(as % of merchandise exports) in Ethiopia in 2010?
Give a very brief answer. 1.59. What is the difference between the Imports(as % of merchandise exports) of Cyprus in 2006 and the Imports(as % of merchandise exports) of Netherlands in 2010?
Offer a very short reply. 2.59. What is the difference between the Imports(as % of merchandise exports) in Ethiopia in 2006 and the Imports(as % of merchandise exports) in Netherlands in 2010?
Offer a very short reply. -1.49. What is the difference between the Imports(as % of merchandise exports) in Least developed countries in 2007 and the Imports(as % of merchandise exports) in Cyprus in 2008?
Make the answer very short. 2.79. What is the difference between the Imports(as % of merchandise exports) in Least developed countries in 2007 and the Imports(as % of merchandise exports) in Ethiopia in 2008?
Your answer should be very brief. 1.86. What is the difference between the Imports(as % of merchandise exports) in Least developed countries in 2007 and the Imports(as % of merchandise exports) in Netherlands in 2008?
Your answer should be very brief. 6.28. What is the difference between the Imports(as % of merchandise exports) in Cyprus in 2007 and the Imports(as % of merchandise exports) in Ethiopia in 2008?
Keep it short and to the point. -1.42. What is the difference between the Imports(as % of merchandise exports) of Cyprus in 2007 and the Imports(as % of merchandise exports) of Netherlands in 2008?
Give a very brief answer. 2.99. What is the difference between the Imports(as % of merchandise exports) of Ethiopia in 2007 and the Imports(as % of merchandise exports) of Netherlands in 2008?
Make the answer very short. -2.89. What is the difference between the Imports(as % of merchandise exports) of Least developed countries in 2007 and the Imports(as % of merchandise exports) of Cyprus in 2009?
Make the answer very short. 0.7. What is the difference between the Imports(as % of merchandise exports) in Least developed countries in 2007 and the Imports(as % of merchandise exports) in Ethiopia in 2009?
Provide a succinct answer. 5.32. What is the difference between the Imports(as % of merchandise exports) of Least developed countries in 2007 and the Imports(as % of merchandise exports) of Netherlands in 2009?
Your response must be concise. 5.24. What is the difference between the Imports(as % of merchandise exports) of Cyprus in 2007 and the Imports(as % of merchandise exports) of Ethiopia in 2009?
Your answer should be very brief. 2.04. What is the difference between the Imports(as % of merchandise exports) in Cyprus in 2007 and the Imports(as % of merchandise exports) in Netherlands in 2009?
Your answer should be very brief. 1.95. What is the difference between the Imports(as % of merchandise exports) of Ethiopia in 2007 and the Imports(as % of merchandise exports) of Netherlands in 2009?
Your response must be concise. -3.93. What is the difference between the Imports(as % of merchandise exports) of Least developed countries in 2007 and the Imports(as % of merchandise exports) of Cyprus in 2010?
Provide a succinct answer. 1.34. What is the difference between the Imports(as % of merchandise exports) in Least developed countries in 2007 and the Imports(as % of merchandise exports) in Ethiopia in 2010?
Ensure brevity in your answer.  5.21. What is the difference between the Imports(as % of merchandise exports) in Least developed countries in 2007 and the Imports(as % of merchandise exports) in Netherlands in 2010?
Your answer should be compact. 6.2. What is the difference between the Imports(as % of merchandise exports) in Cyprus in 2007 and the Imports(as % of merchandise exports) in Ethiopia in 2010?
Your response must be concise. 1.93. What is the difference between the Imports(as % of merchandise exports) of Cyprus in 2007 and the Imports(as % of merchandise exports) of Netherlands in 2010?
Give a very brief answer. 2.92. What is the difference between the Imports(as % of merchandise exports) in Ethiopia in 2007 and the Imports(as % of merchandise exports) in Netherlands in 2010?
Ensure brevity in your answer.  -2.96. What is the difference between the Imports(as % of merchandise exports) of Least developed countries in 2008 and the Imports(as % of merchandise exports) of Cyprus in 2009?
Give a very brief answer. 0.37. What is the difference between the Imports(as % of merchandise exports) of Least developed countries in 2008 and the Imports(as % of merchandise exports) of Ethiopia in 2009?
Keep it short and to the point. 4.99. What is the difference between the Imports(as % of merchandise exports) in Least developed countries in 2008 and the Imports(as % of merchandise exports) in Netherlands in 2009?
Offer a terse response. 4.91. What is the difference between the Imports(as % of merchandise exports) of Cyprus in 2008 and the Imports(as % of merchandise exports) of Ethiopia in 2009?
Offer a very short reply. 2.53. What is the difference between the Imports(as % of merchandise exports) in Cyprus in 2008 and the Imports(as % of merchandise exports) in Netherlands in 2009?
Provide a succinct answer. 2.44. What is the difference between the Imports(as % of merchandise exports) of Ethiopia in 2008 and the Imports(as % of merchandise exports) of Netherlands in 2009?
Keep it short and to the point. 3.38. What is the difference between the Imports(as % of merchandise exports) in Least developed countries in 2008 and the Imports(as % of merchandise exports) in Cyprus in 2010?
Offer a terse response. 1.01. What is the difference between the Imports(as % of merchandise exports) in Least developed countries in 2008 and the Imports(as % of merchandise exports) in Ethiopia in 2010?
Offer a terse response. 4.88. What is the difference between the Imports(as % of merchandise exports) in Least developed countries in 2008 and the Imports(as % of merchandise exports) in Netherlands in 2010?
Provide a short and direct response. 5.88. What is the difference between the Imports(as % of merchandise exports) in Cyprus in 2008 and the Imports(as % of merchandise exports) in Ethiopia in 2010?
Offer a terse response. 2.42. What is the difference between the Imports(as % of merchandise exports) in Cyprus in 2008 and the Imports(as % of merchandise exports) in Netherlands in 2010?
Your response must be concise. 3.41. What is the difference between the Imports(as % of merchandise exports) of Ethiopia in 2008 and the Imports(as % of merchandise exports) of Netherlands in 2010?
Your answer should be compact. 4.34. What is the difference between the Imports(as % of merchandise exports) in Least developed countries in 2009 and the Imports(as % of merchandise exports) in Cyprus in 2010?
Keep it short and to the point. 2.24. What is the difference between the Imports(as % of merchandise exports) of Least developed countries in 2009 and the Imports(as % of merchandise exports) of Ethiopia in 2010?
Offer a terse response. 6.11. What is the difference between the Imports(as % of merchandise exports) of Least developed countries in 2009 and the Imports(as % of merchandise exports) of Netherlands in 2010?
Your answer should be compact. 7.11. What is the difference between the Imports(as % of merchandise exports) in Cyprus in 2009 and the Imports(as % of merchandise exports) in Ethiopia in 2010?
Provide a succinct answer. 4.51. What is the difference between the Imports(as % of merchandise exports) of Cyprus in 2009 and the Imports(as % of merchandise exports) of Netherlands in 2010?
Ensure brevity in your answer.  5.5. What is the difference between the Imports(as % of merchandise exports) in Ethiopia in 2009 and the Imports(as % of merchandise exports) in Netherlands in 2010?
Your response must be concise. 0.89. What is the average Imports(as % of merchandise exports) of Least developed countries per year?
Provide a short and direct response. 16.5. What is the average Imports(as % of merchandise exports) in Cyprus per year?
Provide a succinct answer. 13.21. What is the average Imports(as % of merchandise exports) of Ethiopia per year?
Your answer should be very brief. 12.01. What is the average Imports(as % of merchandise exports) in Netherlands per year?
Give a very brief answer. 9.62. In the year 2003, what is the difference between the Imports(as % of merchandise exports) of Least developed countries and Imports(as % of merchandise exports) of Cyprus?
Provide a short and direct response. 5.26. In the year 2003, what is the difference between the Imports(as % of merchandise exports) in Least developed countries and Imports(as % of merchandise exports) in Ethiopia?
Provide a short and direct response. -4.13. In the year 2003, what is the difference between the Imports(as % of merchandise exports) in Least developed countries and Imports(as % of merchandise exports) in Netherlands?
Offer a terse response. 7.08. In the year 2003, what is the difference between the Imports(as % of merchandise exports) in Cyprus and Imports(as % of merchandise exports) in Ethiopia?
Make the answer very short. -9.38. In the year 2003, what is the difference between the Imports(as % of merchandise exports) in Cyprus and Imports(as % of merchandise exports) in Netherlands?
Make the answer very short. 1.82. In the year 2003, what is the difference between the Imports(as % of merchandise exports) of Ethiopia and Imports(as % of merchandise exports) of Netherlands?
Keep it short and to the point. 11.21. In the year 2004, what is the difference between the Imports(as % of merchandise exports) of Least developed countries and Imports(as % of merchandise exports) of Cyprus?
Offer a very short reply. 4.77. In the year 2004, what is the difference between the Imports(as % of merchandise exports) of Least developed countries and Imports(as % of merchandise exports) of Ethiopia?
Ensure brevity in your answer.  4.46. In the year 2004, what is the difference between the Imports(as % of merchandise exports) in Least developed countries and Imports(as % of merchandise exports) in Netherlands?
Provide a short and direct response. 7.35. In the year 2004, what is the difference between the Imports(as % of merchandise exports) of Cyprus and Imports(as % of merchandise exports) of Ethiopia?
Provide a succinct answer. -0.31. In the year 2004, what is the difference between the Imports(as % of merchandise exports) of Cyprus and Imports(as % of merchandise exports) of Netherlands?
Ensure brevity in your answer.  2.58. In the year 2004, what is the difference between the Imports(as % of merchandise exports) in Ethiopia and Imports(as % of merchandise exports) in Netherlands?
Give a very brief answer. 2.89. In the year 2005, what is the difference between the Imports(as % of merchandise exports) of Least developed countries and Imports(as % of merchandise exports) of Cyprus?
Your answer should be very brief. 3.38. In the year 2005, what is the difference between the Imports(as % of merchandise exports) of Least developed countries and Imports(as % of merchandise exports) of Ethiopia?
Your response must be concise. 5.16. In the year 2005, what is the difference between the Imports(as % of merchandise exports) in Least developed countries and Imports(as % of merchandise exports) in Netherlands?
Your answer should be compact. 6.95. In the year 2005, what is the difference between the Imports(as % of merchandise exports) of Cyprus and Imports(as % of merchandise exports) of Ethiopia?
Your answer should be compact. 1.78. In the year 2005, what is the difference between the Imports(as % of merchandise exports) in Cyprus and Imports(as % of merchandise exports) in Netherlands?
Give a very brief answer. 3.57. In the year 2005, what is the difference between the Imports(as % of merchandise exports) in Ethiopia and Imports(as % of merchandise exports) in Netherlands?
Your response must be concise. 1.79. In the year 2006, what is the difference between the Imports(as % of merchandise exports) of Least developed countries and Imports(as % of merchandise exports) of Cyprus?
Give a very brief answer. 3.41. In the year 2006, what is the difference between the Imports(as % of merchandise exports) in Least developed countries and Imports(as % of merchandise exports) in Ethiopia?
Give a very brief answer. 7.48. In the year 2006, what is the difference between the Imports(as % of merchandise exports) of Least developed countries and Imports(as % of merchandise exports) of Netherlands?
Provide a short and direct response. 7.51. In the year 2006, what is the difference between the Imports(as % of merchandise exports) in Cyprus and Imports(as % of merchandise exports) in Ethiopia?
Ensure brevity in your answer.  4.07. In the year 2006, what is the difference between the Imports(as % of merchandise exports) in Cyprus and Imports(as % of merchandise exports) in Netherlands?
Provide a succinct answer. 4.1. In the year 2006, what is the difference between the Imports(as % of merchandise exports) of Ethiopia and Imports(as % of merchandise exports) of Netherlands?
Provide a short and direct response. 0.03. In the year 2007, what is the difference between the Imports(as % of merchandise exports) in Least developed countries and Imports(as % of merchandise exports) in Cyprus?
Offer a very short reply. 3.28. In the year 2007, what is the difference between the Imports(as % of merchandise exports) in Least developed countries and Imports(as % of merchandise exports) in Ethiopia?
Offer a very short reply. 9.17. In the year 2007, what is the difference between the Imports(as % of merchandise exports) in Least developed countries and Imports(as % of merchandise exports) in Netherlands?
Offer a very short reply. 7.04. In the year 2007, what is the difference between the Imports(as % of merchandise exports) of Cyprus and Imports(as % of merchandise exports) of Ethiopia?
Your answer should be very brief. 5.88. In the year 2007, what is the difference between the Imports(as % of merchandise exports) of Cyprus and Imports(as % of merchandise exports) of Netherlands?
Provide a succinct answer. 3.76. In the year 2007, what is the difference between the Imports(as % of merchandise exports) of Ethiopia and Imports(as % of merchandise exports) of Netherlands?
Your answer should be very brief. -2.12. In the year 2008, what is the difference between the Imports(as % of merchandise exports) in Least developed countries and Imports(as % of merchandise exports) in Cyprus?
Your answer should be very brief. 2.47. In the year 2008, what is the difference between the Imports(as % of merchandise exports) in Least developed countries and Imports(as % of merchandise exports) in Ethiopia?
Your answer should be very brief. 1.53. In the year 2008, what is the difference between the Imports(as % of merchandise exports) in Least developed countries and Imports(as % of merchandise exports) in Netherlands?
Offer a very short reply. 5.95. In the year 2008, what is the difference between the Imports(as % of merchandise exports) in Cyprus and Imports(as % of merchandise exports) in Ethiopia?
Keep it short and to the point. -0.93. In the year 2008, what is the difference between the Imports(as % of merchandise exports) in Cyprus and Imports(as % of merchandise exports) in Netherlands?
Offer a terse response. 3.48. In the year 2008, what is the difference between the Imports(as % of merchandise exports) of Ethiopia and Imports(as % of merchandise exports) of Netherlands?
Ensure brevity in your answer.  4.42. In the year 2009, what is the difference between the Imports(as % of merchandise exports) in Least developed countries and Imports(as % of merchandise exports) in Cyprus?
Offer a very short reply. 1.6. In the year 2009, what is the difference between the Imports(as % of merchandise exports) of Least developed countries and Imports(as % of merchandise exports) of Ethiopia?
Make the answer very short. 6.22. In the year 2009, what is the difference between the Imports(as % of merchandise exports) in Least developed countries and Imports(as % of merchandise exports) in Netherlands?
Give a very brief answer. 6.14. In the year 2009, what is the difference between the Imports(as % of merchandise exports) in Cyprus and Imports(as % of merchandise exports) in Ethiopia?
Your answer should be very brief. 4.62. In the year 2009, what is the difference between the Imports(as % of merchandise exports) in Cyprus and Imports(as % of merchandise exports) in Netherlands?
Your response must be concise. 4.54. In the year 2009, what is the difference between the Imports(as % of merchandise exports) of Ethiopia and Imports(as % of merchandise exports) of Netherlands?
Ensure brevity in your answer.  -0.08. In the year 2010, what is the difference between the Imports(as % of merchandise exports) in Least developed countries and Imports(as % of merchandise exports) in Cyprus?
Give a very brief answer. 2.18. In the year 2010, what is the difference between the Imports(as % of merchandise exports) in Least developed countries and Imports(as % of merchandise exports) in Ethiopia?
Offer a terse response. 6.06. In the year 2010, what is the difference between the Imports(as % of merchandise exports) of Least developed countries and Imports(as % of merchandise exports) of Netherlands?
Provide a short and direct response. 7.05. In the year 2010, what is the difference between the Imports(as % of merchandise exports) in Cyprus and Imports(as % of merchandise exports) in Ethiopia?
Your answer should be very brief. 3.87. In the year 2010, what is the difference between the Imports(as % of merchandise exports) of Cyprus and Imports(as % of merchandise exports) of Netherlands?
Your answer should be compact. 4.87. In the year 2010, what is the difference between the Imports(as % of merchandise exports) of Ethiopia and Imports(as % of merchandise exports) of Netherlands?
Keep it short and to the point. 1. What is the ratio of the Imports(as % of merchandise exports) in Least developed countries in 2003 to that in 2004?
Make the answer very short. 1.04. What is the ratio of the Imports(as % of merchandise exports) in Cyprus in 2003 to that in 2004?
Offer a terse response. 1.01. What is the ratio of the Imports(as % of merchandise exports) in Ethiopia in 2003 to that in 2004?
Give a very brief answer. 1.75. What is the ratio of the Imports(as % of merchandise exports) in Netherlands in 2003 to that in 2004?
Provide a succinct answer. 1.09. What is the ratio of the Imports(as % of merchandise exports) of Least developed countries in 2003 to that in 2005?
Give a very brief answer. 1.1. What is the ratio of the Imports(as % of merchandise exports) of Cyprus in 2003 to that in 2005?
Keep it short and to the point. 0.97. What is the ratio of the Imports(as % of merchandise exports) of Ethiopia in 2003 to that in 2005?
Ensure brevity in your answer.  2.02. What is the ratio of the Imports(as % of merchandise exports) of Netherlands in 2003 to that in 2005?
Give a very brief answer. 1.16. What is the ratio of the Imports(as % of merchandise exports) in Least developed countries in 2003 to that in 2006?
Provide a short and direct response. 1.09. What is the ratio of the Imports(as % of merchandise exports) in Cyprus in 2003 to that in 2006?
Your answer should be compact. 0.96. What is the ratio of the Imports(as % of merchandise exports) of Ethiopia in 2003 to that in 2006?
Your response must be concise. 2.53. What is the ratio of the Imports(as % of merchandise exports) in Netherlands in 2003 to that in 2006?
Your answer should be very brief. 1.21. What is the ratio of the Imports(as % of merchandise exports) of Least developed countries in 2003 to that in 2007?
Make the answer very short. 1.07. What is the ratio of the Imports(as % of merchandise exports) in Cyprus in 2003 to that in 2007?
Ensure brevity in your answer.  0.94. What is the ratio of the Imports(as % of merchandise exports) in Ethiopia in 2003 to that in 2007?
Offer a very short reply. 3.06. What is the ratio of the Imports(as % of merchandise exports) in Netherlands in 2003 to that in 2007?
Give a very brief answer. 1.12. What is the ratio of the Imports(as % of merchandise exports) of Least developed countries in 2003 to that in 2008?
Provide a short and direct response. 1.09. What is the ratio of the Imports(as % of merchandise exports) in Cyprus in 2003 to that in 2008?
Ensure brevity in your answer.  0.9. What is the ratio of the Imports(as % of merchandise exports) of Ethiopia in 2003 to that in 2008?
Give a very brief answer. 1.5. What is the ratio of the Imports(as % of merchandise exports) of Netherlands in 2003 to that in 2008?
Provide a succinct answer. 1.04. What is the ratio of the Imports(as % of merchandise exports) in Least developed countries in 2003 to that in 2009?
Ensure brevity in your answer.  1.02. What is the ratio of the Imports(as % of merchandise exports) of Cyprus in 2003 to that in 2009?
Ensure brevity in your answer.  0.78. What is the ratio of the Imports(as % of merchandise exports) of Ethiopia in 2003 to that in 2009?
Provide a succinct answer. 1.98. What is the ratio of the Imports(as % of merchandise exports) of Netherlands in 2003 to that in 2009?
Offer a very short reply. 0.94. What is the ratio of the Imports(as % of merchandise exports) in Least developed countries in 2003 to that in 2010?
Provide a short and direct response. 1.02. What is the ratio of the Imports(as % of merchandise exports) in Cyprus in 2003 to that in 2010?
Provide a short and direct response. 0.81. What is the ratio of the Imports(as % of merchandise exports) of Ethiopia in 2003 to that in 2010?
Offer a terse response. 1.96. What is the ratio of the Imports(as % of merchandise exports) in Netherlands in 2003 to that in 2010?
Ensure brevity in your answer.  1.03. What is the ratio of the Imports(as % of merchandise exports) in Least developed countries in 2004 to that in 2005?
Ensure brevity in your answer.  1.06. What is the ratio of the Imports(as % of merchandise exports) of Cyprus in 2004 to that in 2005?
Ensure brevity in your answer.  0.96. What is the ratio of the Imports(as % of merchandise exports) of Ethiopia in 2004 to that in 2005?
Your response must be concise. 1.16. What is the ratio of the Imports(as % of merchandise exports) in Netherlands in 2004 to that in 2005?
Offer a very short reply. 1.06. What is the ratio of the Imports(as % of merchandise exports) of Least developed countries in 2004 to that in 2006?
Your answer should be very brief. 1.05. What is the ratio of the Imports(as % of merchandise exports) of Cyprus in 2004 to that in 2006?
Provide a short and direct response. 0.95. What is the ratio of the Imports(as % of merchandise exports) in Ethiopia in 2004 to that in 2006?
Provide a succinct answer. 1.45. What is the ratio of the Imports(as % of merchandise exports) of Netherlands in 2004 to that in 2006?
Your response must be concise. 1.11. What is the ratio of the Imports(as % of merchandise exports) in Least developed countries in 2004 to that in 2007?
Your response must be concise. 1.04. What is the ratio of the Imports(as % of merchandise exports) in Cyprus in 2004 to that in 2007?
Provide a short and direct response. 0.93. What is the ratio of the Imports(as % of merchandise exports) in Ethiopia in 2004 to that in 2007?
Your answer should be very brief. 1.75. What is the ratio of the Imports(as % of merchandise exports) of Netherlands in 2004 to that in 2007?
Offer a very short reply. 1.03. What is the ratio of the Imports(as % of merchandise exports) in Least developed countries in 2004 to that in 2008?
Give a very brief answer. 1.06. What is the ratio of the Imports(as % of merchandise exports) of Cyprus in 2004 to that in 2008?
Give a very brief answer. 0.9. What is the ratio of the Imports(as % of merchandise exports) of Ethiopia in 2004 to that in 2008?
Provide a succinct answer. 0.86. What is the ratio of the Imports(as % of merchandise exports) of Netherlands in 2004 to that in 2008?
Offer a very short reply. 0.95. What is the ratio of the Imports(as % of merchandise exports) in Cyprus in 2004 to that in 2009?
Your answer should be compact. 0.77. What is the ratio of the Imports(as % of merchandise exports) of Ethiopia in 2004 to that in 2009?
Offer a very short reply. 1.13. What is the ratio of the Imports(as % of merchandise exports) in Netherlands in 2004 to that in 2009?
Your answer should be compact. 0.86. What is the ratio of the Imports(as % of merchandise exports) of Least developed countries in 2004 to that in 2010?
Provide a short and direct response. 0.98. What is the ratio of the Imports(as % of merchandise exports) in Cyprus in 2004 to that in 2010?
Ensure brevity in your answer.  0.81. What is the ratio of the Imports(as % of merchandise exports) in Ethiopia in 2004 to that in 2010?
Ensure brevity in your answer.  1.12. What is the ratio of the Imports(as % of merchandise exports) of Netherlands in 2004 to that in 2010?
Keep it short and to the point. 0.94. What is the ratio of the Imports(as % of merchandise exports) in Least developed countries in 2005 to that in 2006?
Provide a succinct answer. 0.99. What is the ratio of the Imports(as % of merchandise exports) in Ethiopia in 2005 to that in 2006?
Offer a very short reply. 1.25. What is the ratio of the Imports(as % of merchandise exports) of Netherlands in 2005 to that in 2006?
Give a very brief answer. 1.05. What is the ratio of the Imports(as % of merchandise exports) of Least developed countries in 2005 to that in 2007?
Offer a very short reply. 0.98. What is the ratio of the Imports(as % of merchandise exports) in Cyprus in 2005 to that in 2007?
Give a very brief answer. 0.96. What is the ratio of the Imports(as % of merchandise exports) in Ethiopia in 2005 to that in 2007?
Give a very brief answer. 1.52. What is the ratio of the Imports(as % of merchandise exports) in Netherlands in 2005 to that in 2007?
Your answer should be compact. 0.97. What is the ratio of the Imports(as % of merchandise exports) of Least developed countries in 2005 to that in 2008?
Ensure brevity in your answer.  1. What is the ratio of the Imports(as % of merchandise exports) in Cyprus in 2005 to that in 2008?
Provide a succinct answer. 0.93. What is the ratio of the Imports(as % of merchandise exports) of Ethiopia in 2005 to that in 2008?
Make the answer very short. 0.74. What is the ratio of the Imports(as % of merchandise exports) in Netherlands in 2005 to that in 2008?
Provide a short and direct response. 0.89. What is the ratio of the Imports(as % of merchandise exports) in Least developed countries in 2005 to that in 2009?
Keep it short and to the point. 0.93. What is the ratio of the Imports(as % of merchandise exports) of Cyprus in 2005 to that in 2009?
Give a very brief answer. 0.8. What is the ratio of the Imports(as % of merchandise exports) in Ethiopia in 2005 to that in 2009?
Make the answer very short. 0.98. What is the ratio of the Imports(as % of merchandise exports) in Netherlands in 2005 to that in 2009?
Your response must be concise. 0.81. What is the ratio of the Imports(as % of merchandise exports) in Least developed countries in 2005 to that in 2010?
Your response must be concise. 0.93. What is the ratio of the Imports(as % of merchandise exports) in Cyprus in 2005 to that in 2010?
Keep it short and to the point. 0.84. What is the ratio of the Imports(as % of merchandise exports) of Ethiopia in 2005 to that in 2010?
Give a very brief answer. 0.97. What is the ratio of the Imports(as % of merchandise exports) in Netherlands in 2005 to that in 2010?
Your answer should be very brief. 0.89. What is the ratio of the Imports(as % of merchandise exports) in Least developed countries in 2006 to that in 2007?
Your response must be concise. 0.99. What is the ratio of the Imports(as % of merchandise exports) of Cyprus in 2006 to that in 2007?
Keep it short and to the point. 0.97. What is the ratio of the Imports(as % of merchandise exports) of Ethiopia in 2006 to that in 2007?
Make the answer very short. 1.21. What is the ratio of the Imports(as % of merchandise exports) in Netherlands in 2006 to that in 2007?
Make the answer very short. 0.93. What is the ratio of the Imports(as % of merchandise exports) of Least developed countries in 2006 to that in 2008?
Your response must be concise. 1.01. What is the ratio of the Imports(as % of merchandise exports) of Cyprus in 2006 to that in 2008?
Your answer should be compact. 0.94. What is the ratio of the Imports(as % of merchandise exports) in Ethiopia in 2006 to that in 2008?
Provide a short and direct response. 0.59. What is the ratio of the Imports(as % of merchandise exports) of Netherlands in 2006 to that in 2008?
Ensure brevity in your answer.  0.85. What is the ratio of the Imports(as % of merchandise exports) in Least developed countries in 2006 to that in 2009?
Ensure brevity in your answer.  0.93. What is the ratio of the Imports(as % of merchandise exports) of Cyprus in 2006 to that in 2009?
Keep it short and to the point. 0.81. What is the ratio of the Imports(as % of merchandise exports) in Ethiopia in 2006 to that in 2009?
Ensure brevity in your answer.  0.78. What is the ratio of the Imports(as % of merchandise exports) of Netherlands in 2006 to that in 2009?
Ensure brevity in your answer.  0.77. What is the ratio of the Imports(as % of merchandise exports) of Least developed countries in 2006 to that in 2010?
Your answer should be very brief. 0.94. What is the ratio of the Imports(as % of merchandise exports) in Cyprus in 2006 to that in 2010?
Your answer should be compact. 0.85. What is the ratio of the Imports(as % of merchandise exports) of Ethiopia in 2006 to that in 2010?
Your answer should be compact. 0.77. What is the ratio of the Imports(as % of merchandise exports) of Netherlands in 2006 to that in 2010?
Offer a very short reply. 0.85. What is the ratio of the Imports(as % of merchandise exports) of Least developed countries in 2007 to that in 2008?
Your answer should be compact. 1.02. What is the ratio of the Imports(as % of merchandise exports) of Cyprus in 2007 to that in 2008?
Ensure brevity in your answer.  0.96. What is the ratio of the Imports(as % of merchandise exports) of Ethiopia in 2007 to that in 2008?
Your response must be concise. 0.49. What is the ratio of the Imports(as % of merchandise exports) in Netherlands in 2007 to that in 2008?
Provide a succinct answer. 0.92. What is the ratio of the Imports(as % of merchandise exports) in Least developed countries in 2007 to that in 2009?
Offer a terse response. 0.95. What is the ratio of the Imports(as % of merchandise exports) of Cyprus in 2007 to that in 2009?
Keep it short and to the point. 0.83. What is the ratio of the Imports(as % of merchandise exports) of Ethiopia in 2007 to that in 2009?
Make the answer very short. 0.65. What is the ratio of the Imports(as % of merchandise exports) of Netherlands in 2007 to that in 2009?
Your response must be concise. 0.83. What is the ratio of the Imports(as % of merchandise exports) of Least developed countries in 2007 to that in 2010?
Give a very brief answer. 0.95. What is the ratio of the Imports(as % of merchandise exports) in Cyprus in 2007 to that in 2010?
Your answer should be compact. 0.87. What is the ratio of the Imports(as % of merchandise exports) of Ethiopia in 2007 to that in 2010?
Provide a short and direct response. 0.64. What is the ratio of the Imports(as % of merchandise exports) in Netherlands in 2007 to that in 2010?
Your response must be concise. 0.92. What is the ratio of the Imports(as % of merchandise exports) in Least developed countries in 2008 to that in 2009?
Offer a very short reply. 0.93. What is the ratio of the Imports(as % of merchandise exports) of Cyprus in 2008 to that in 2009?
Offer a very short reply. 0.86. What is the ratio of the Imports(as % of merchandise exports) in Ethiopia in 2008 to that in 2009?
Offer a very short reply. 1.32. What is the ratio of the Imports(as % of merchandise exports) in Netherlands in 2008 to that in 2009?
Ensure brevity in your answer.  0.9. What is the ratio of the Imports(as % of merchandise exports) of Least developed countries in 2008 to that in 2010?
Your answer should be compact. 0.93. What is the ratio of the Imports(as % of merchandise exports) in Cyprus in 2008 to that in 2010?
Offer a terse response. 0.9. What is the ratio of the Imports(as % of merchandise exports) in Ethiopia in 2008 to that in 2010?
Offer a terse response. 1.31. What is the ratio of the Imports(as % of merchandise exports) in Cyprus in 2009 to that in 2010?
Your answer should be very brief. 1.04. What is the ratio of the Imports(as % of merchandise exports) of Netherlands in 2009 to that in 2010?
Give a very brief answer. 1.1. What is the difference between the highest and the second highest Imports(as % of merchandise exports) of Least developed countries?
Offer a terse response. 0.27. What is the difference between the highest and the second highest Imports(as % of merchandise exports) of Cyprus?
Your answer should be compact. 0.64. What is the difference between the highest and the second highest Imports(as % of merchandise exports) in Ethiopia?
Make the answer very short. 7.16. What is the difference between the highest and the second highest Imports(as % of merchandise exports) in Netherlands?
Your response must be concise. 0.67. What is the difference between the highest and the lowest Imports(as % of merchandise exports) of Least developed countries?
Provide a short and direct response. 1.54. What is the difference between the highest and the lowest Imports(as % of merchandise exports) in Cyprus?
Provide a short and direct response. 3.5. What is the difference between the highest and the lowest Imports(as % of merchandise exports) of Ethiopia?
Give a very brief answer. 14.46. What is the difference between the highest and the lowest Imports(as % of merchandise exports) of Netherlands?
Your answer should be very brief. 2.48. 